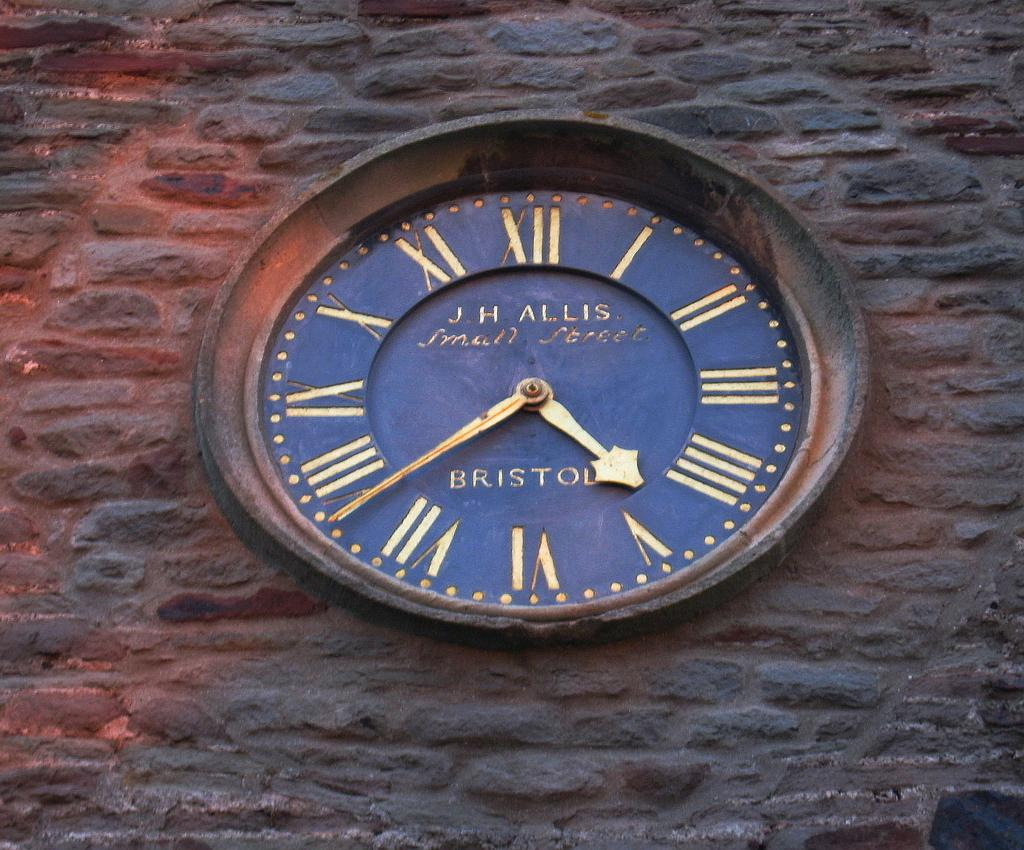<image>
Offer a succinct explanation of the picture presented. A J.H. Allis clock on the side of a stone building. 